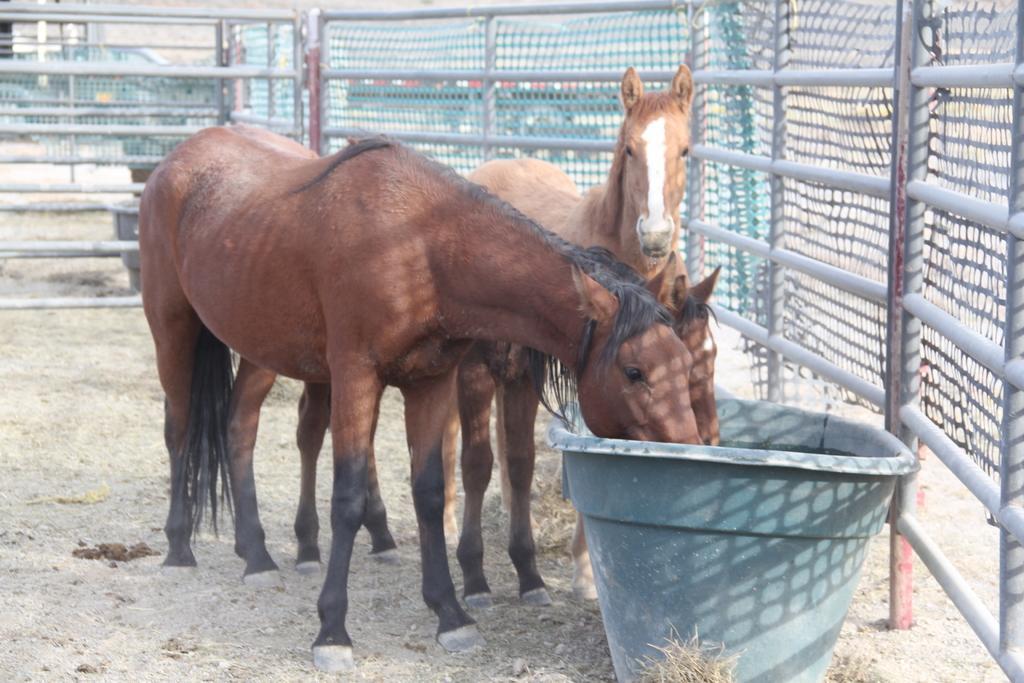Describe this image in one or two sentences. In this image I see 3 horses in front and I see a grey color thing near to them and I see the grass. In the background I see the fencing. 